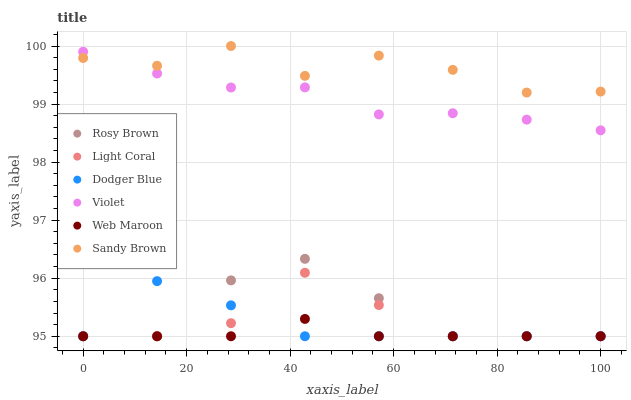Does Web Maroon have the minimum area under the curve?
Answer yes or no. Yes. Does Sandy Brown have the maximum area under the curve?
Answer yes or no. Yes. Does Light Coral have the minimum area under the curve?
Answer yes or no. No. Does Light Coral have the maximum area under the curve?
Answer yes or no. No. Is Web Maroon the smoothest?
Answer yes or no. Yes. Is Sandy Brown the roughest?
Answer yes or no. Yes. Is Light Coral the smoothest?
Answer yes or no. No. Is Light Coral the roughest?
Answer yes or no. No. Does Rosy Brown have the lowest value?
Answer yes or no. Yes. Does Violet have the lowest value?
Answer yes or no. No. Does Sandy Brown have the highest value?
Answer yes or no. Yes. Does Light Coral have the highest value?
Answer yes or no. No. Is Dodger Blue less than Violet?
Answer yes or no. Yes. Is Sandy Brown greater than Light Coral?
Answer yes or no. Yes. Does Rosy Brown intersect Light Coral?
Answer yes or no. Yes. Is Rosy Brown less than Light Coral?
Answer yes or no. No. Is Rosy Brown greater than Light Coral?
Answer yes or no. No. Does Dodger Blue intersect Violet?
Answer yes or no. No. 